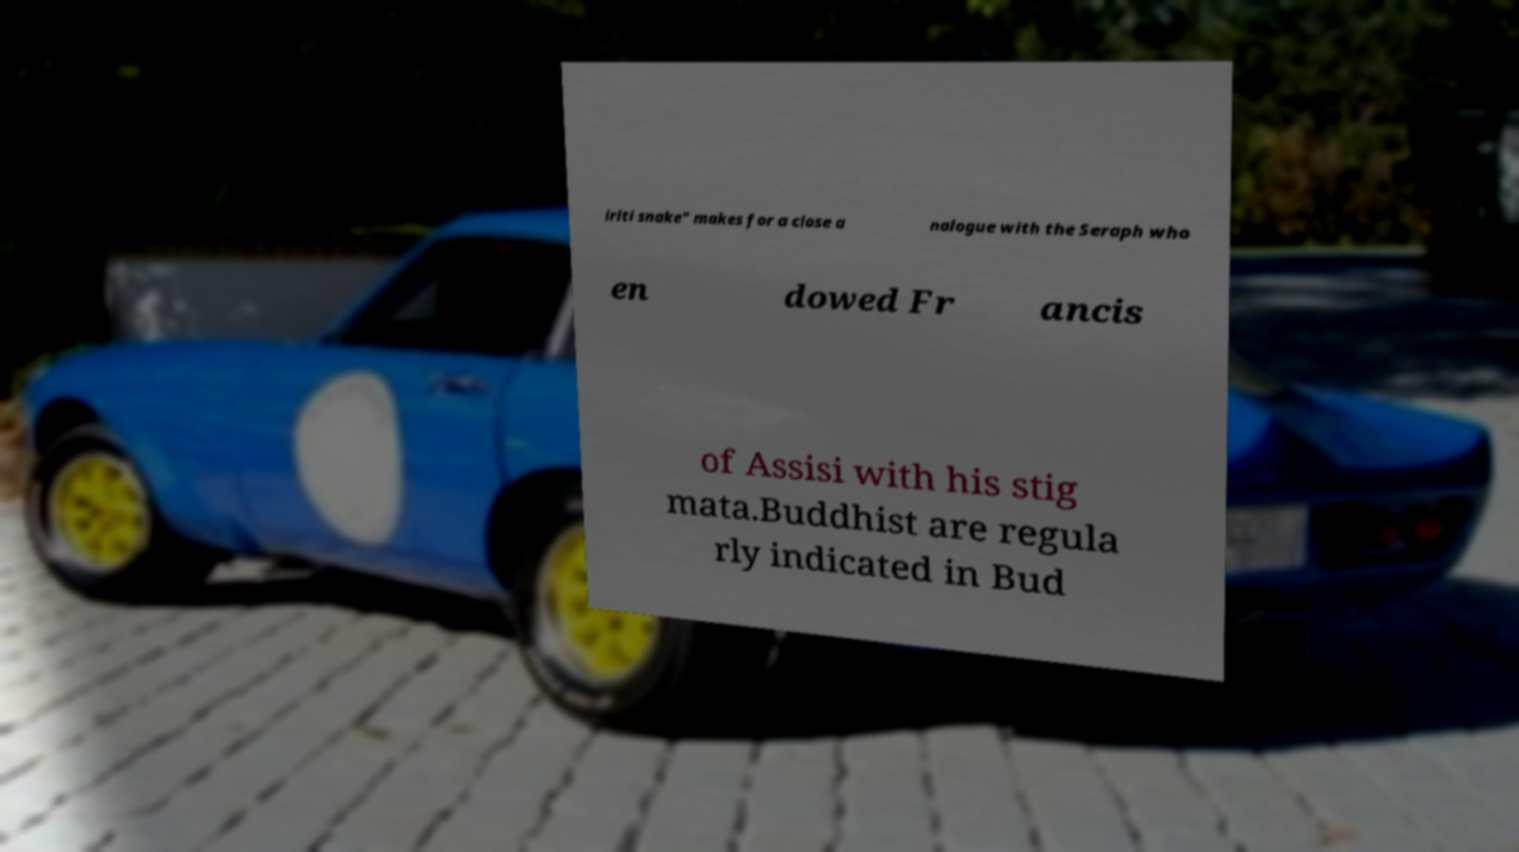I need the written content from this picture converted into text. Can you do that? iriti snake" makes for a close a nalogue with the Seraph who en dowed Fr ancis of Assisi with his stig mata.Buddhist are regula rly indicated in Bud 